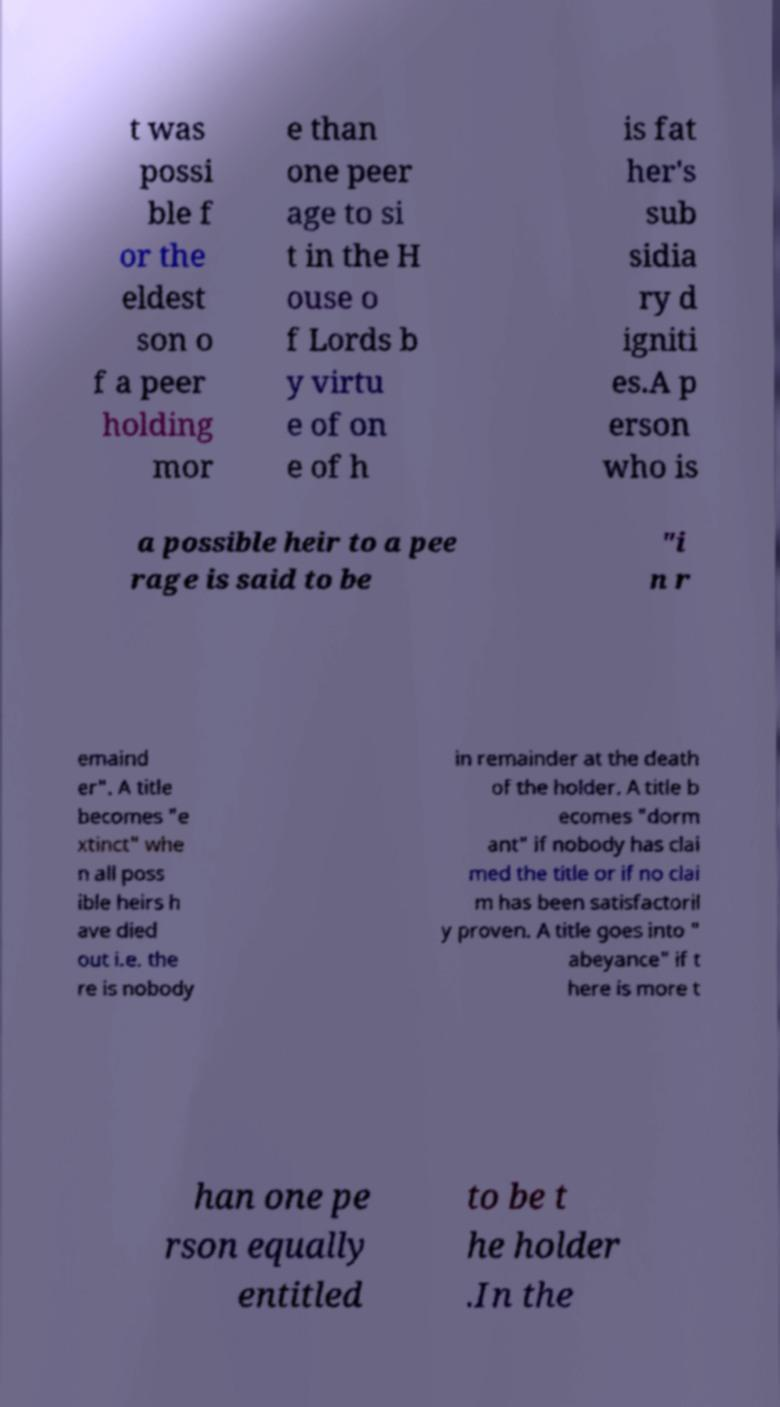For documentation purposes, I need the text within this image transcribed. Could you provide that? t was possi ble f or the eldest son o f a peer holding mor e than one peer age to si t in the H ouse o f Lords b y virtu e of on e of h is fat her's sub sidia ry d igniti es.A p erson who is a possible heir to a pee rage is said to be "i n r emaind er". A title becomes "e xtinct" whe n all poss ible heirs h ave died out i.e. the re is nobody in remainder at the death of the holder. A title b ecomes "dorm ant" if nobody has clai med the title or if no clai m has been satisfactoril y proven. A title goes into " abeyance" if t here is more t han one pe rson equally entitled to be t he holder .In the 